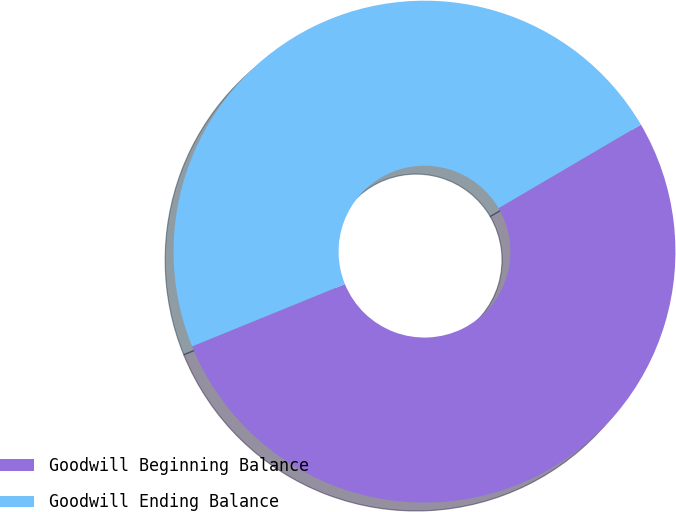<chart> <loc_0><loc_0><loc_500><loc_500><pie_chart><fcel>Goodwill Beginning Balance<fcel>Goodwill Ending Balance<nl><fcel>52.29%<fcel>47.71%<nl></chart> 